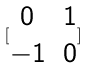<formula> <loc_0><loc_0><loc_500><loc_500>[ \begin{matrix} 0 & 1 \\ - 1 & 0 \end{matrix} ]</formula> 